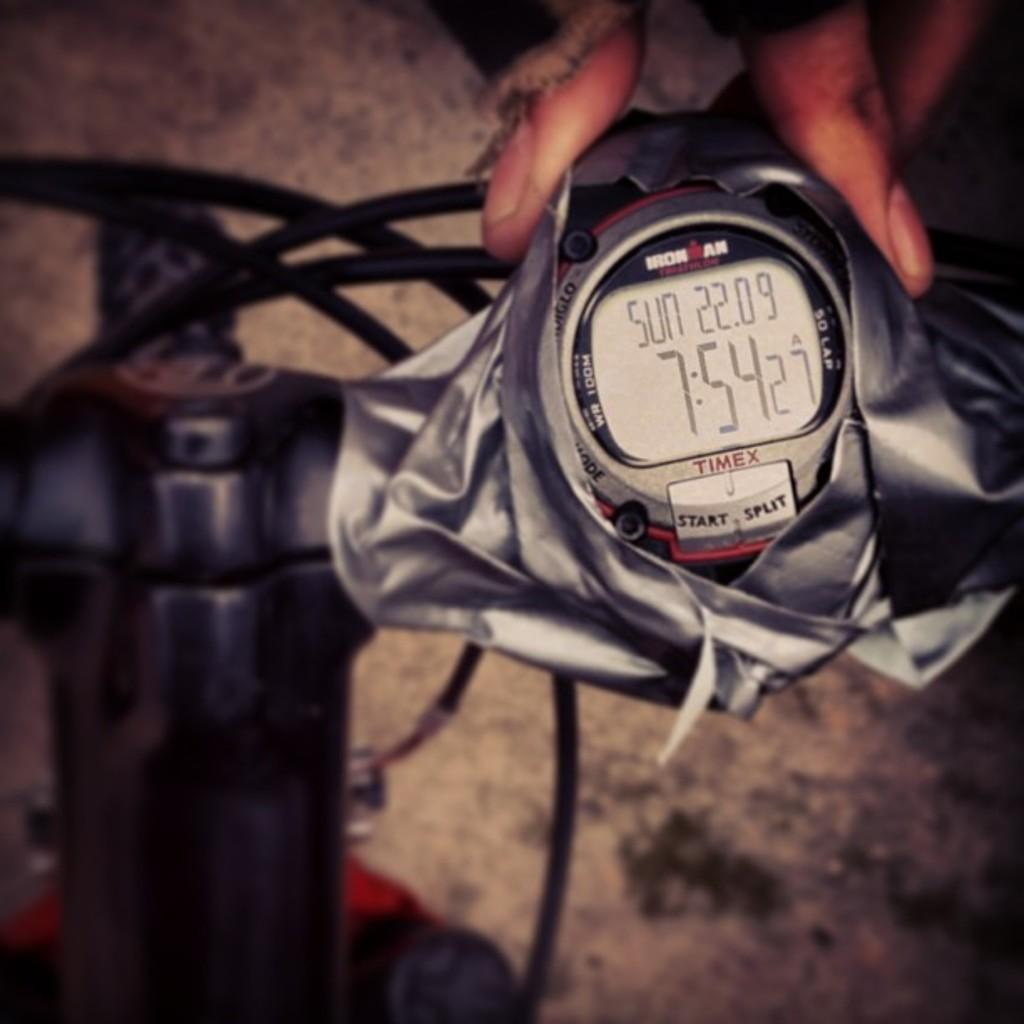Provide a one-sentence caption for the provided image. The Timex timepiece recorded the date as Sunday the 22nd of '09 and the time as 7:54:27am. 